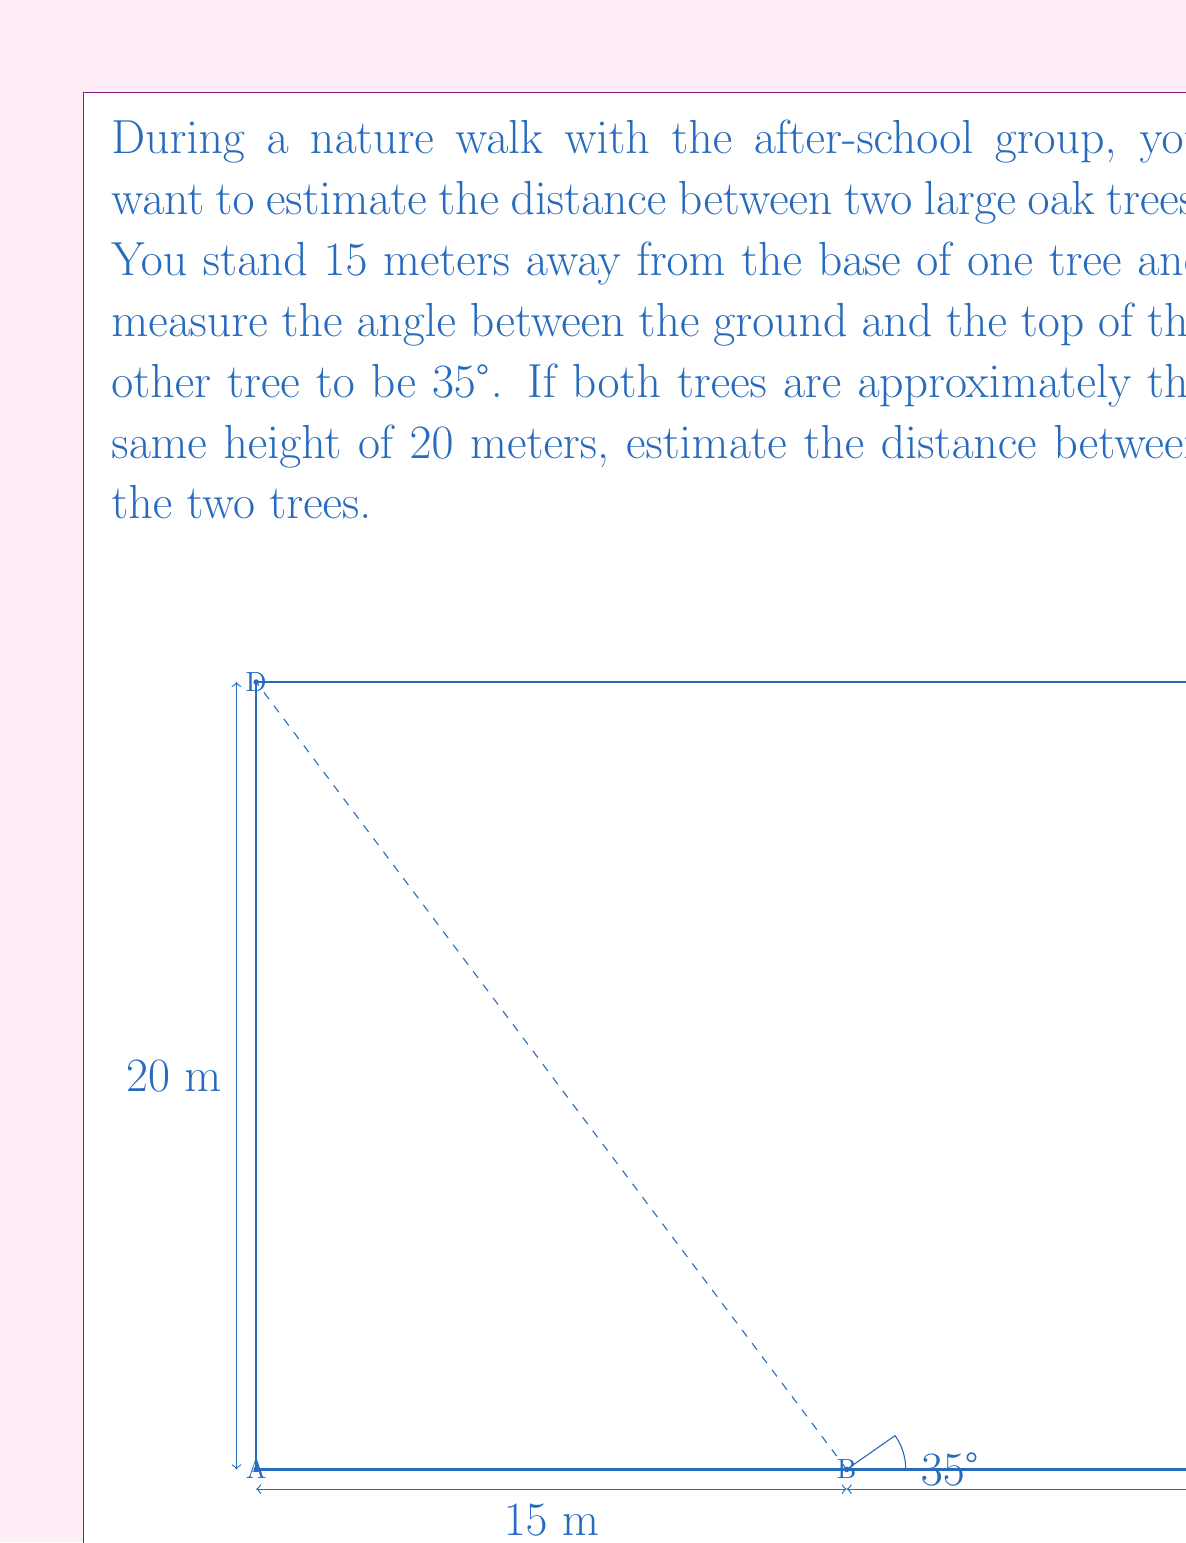Provide a solution to this math problem. Let's approach this problem step by step:

1) First, we need to identify the trigonometric ratio we'll use. In this case, we'll use the tangent ratio.

2) From the diagram, we can see that we have a right triangle formed by the observer's position (B), the base of the far tree (C), and the top of the far tree (E).

3) We know:
   - The adjacent side (BC) is what we're trying to find. Let's call this $x$.
   - The opposite side (BE) is the height of the tree minus the observer's height. 
     Let's assume the observer's eye level is about 1.6 meters high.
     So, BE = 20 - 1.6 = 18.4 meters

4) The tangent of an angle is the ratio of the opposite side to the adjacent side:

   $$\tan(35°) = \frac{\text{opposite}}{\text{adjacent}} = \frac{18.4}{x}$$

5) We can rearrange this equation to solve for $x$:

   $$x = \frac{18.4}{\tan(35°)}$$

6) Using a calculator (or trigonometric tables):

   $$x = \frac{18.4}{0.7002} \approx 26.28 \text{ meters}$$

7) Now we know the distance from the observer to the far tree. To find the distance between the trees, we need to add the 15 meters from the observer to the near tree:

   Distance between trees = 26.28 + 15 = 41.28 meters

8) Since we're estimating, we can round this to 41 meters.
Answer: The estimated distance between the two trees is approximately 41 meters. 